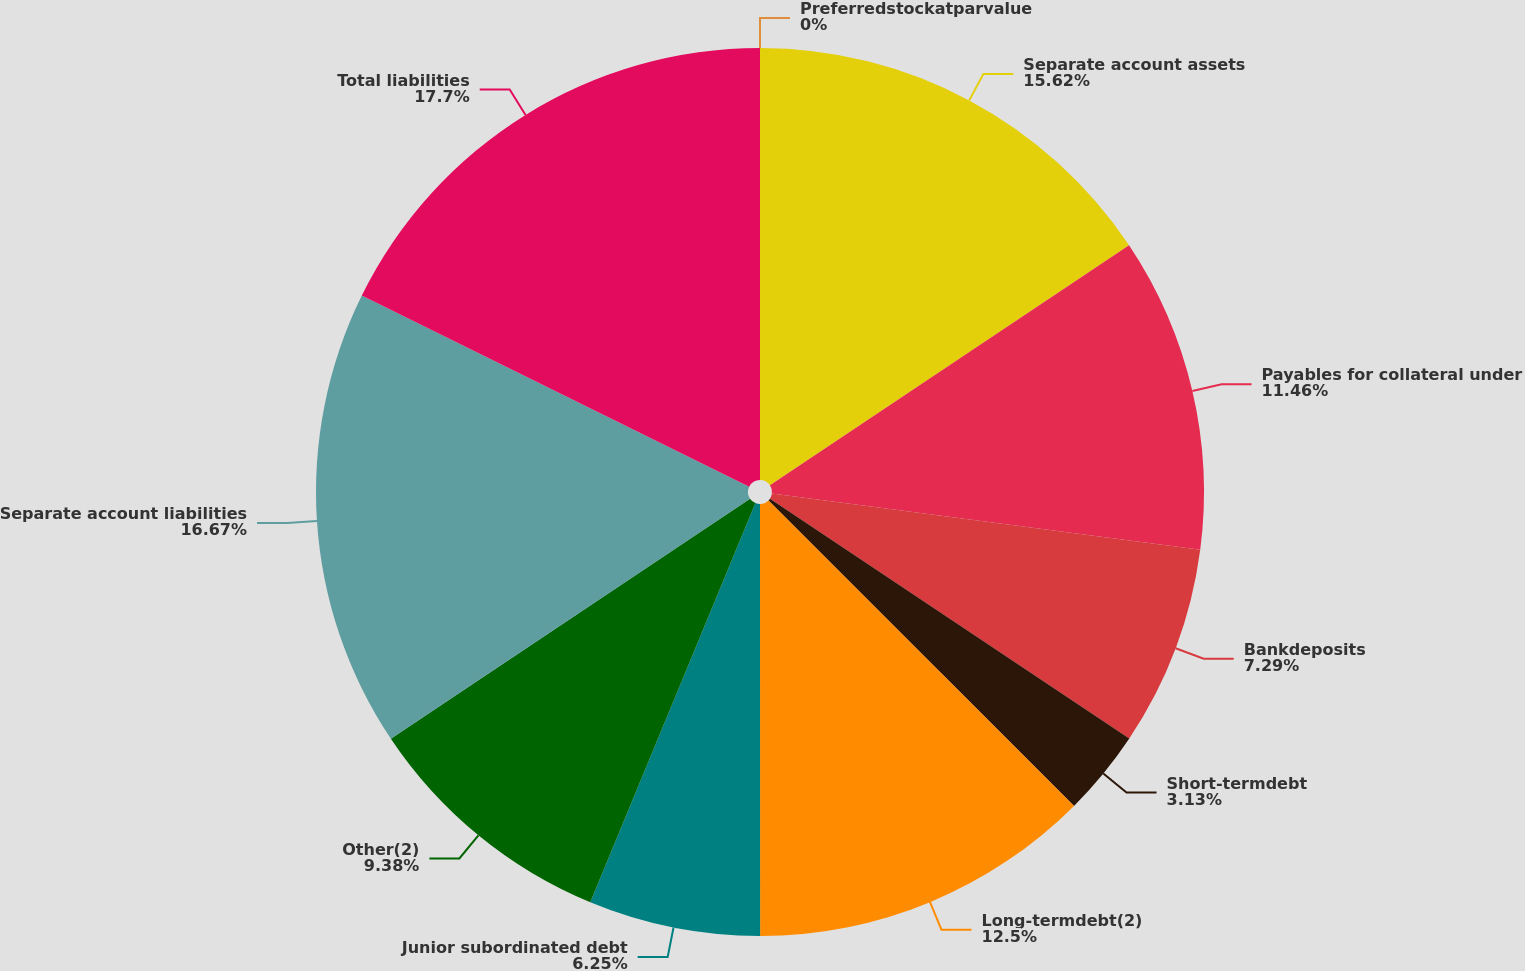Convert chart. <chart><loc_0><loc_0><loc_500><loc_500><pie_chart><fcel>Separate account assets<fcel>Payables for collateral under<fcel>Bankdeposits<fcel>Short-termdebt<fcel>Long-termdebt(2)<fcel>Junior subordinated debt<fcel>Other(2)<fcel>Separate account liabilities<fcel>Total liabilities<fcel>Preferredstockatparvalue<nl><fcel>15.62%<fcel>11.46%<fcel>7.29%<fcel>3.13%<fcel>12.5%<fcel>6.25%<fcel>9.38%<fcel>16.67%<fcel>17.71%<fcel>0.0%<nl></chart> 